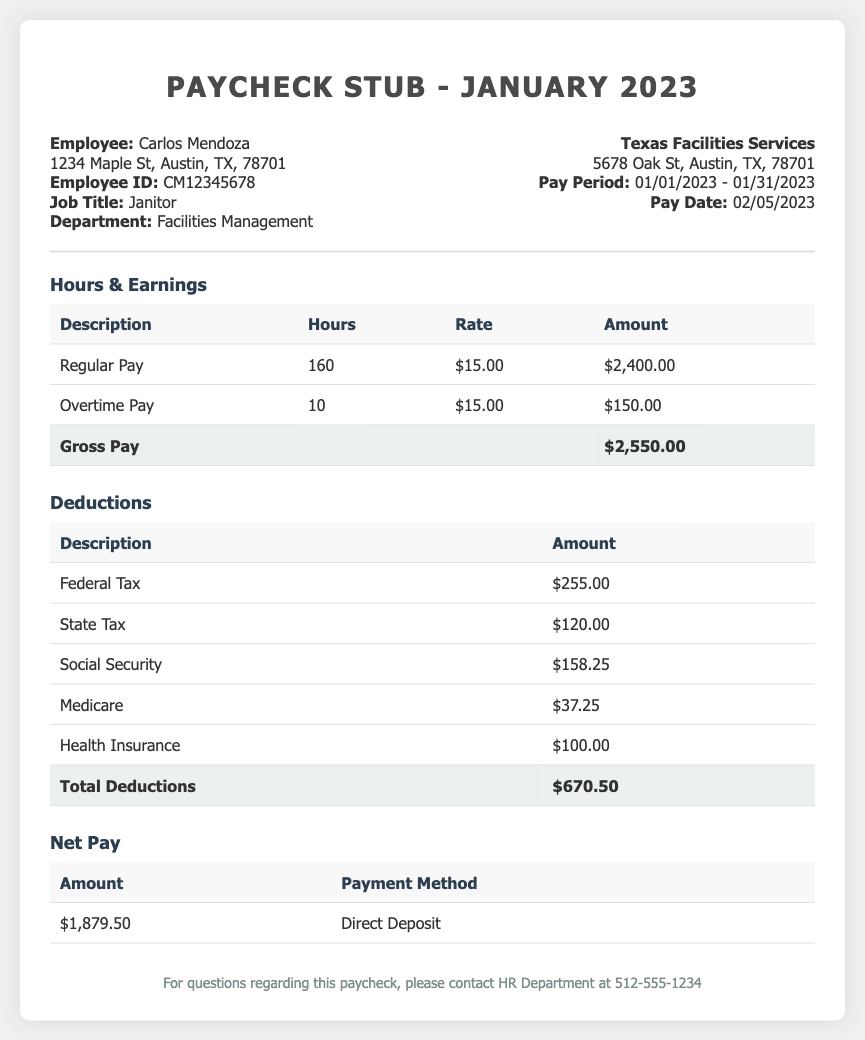What is the employee's name? The employee's name is listed in the document as Carlos Mendoza.
Answer: Carlos Mendoza What is the pay period? The pay period is specified in the document as the time span from January 1, 2023 to January 31, 2023.
Answer: 01/01/2023 - 01/31/2023 How many hours of overtime were worked? The overtime hours are listed in the earnings section of the document as 10 hours.
Answer: 10 What is the total gross pay? The total gross pay is provided in the earnings section as $2,550.00.
Answer: $2,550.00 What is the amount deducted for federal tax? The deduction for federal tax is specified in the deductions section of the document as $255.00.
Answer: $255.00 What is the net pay amount? The net pay amount is stated in the document as $1,879.50.
Answer: $1,879.50 What payment method was used? The payment method for the net pay is indicated as direct deposit in the document.
Answer: Direct Deposit What is the total amount of deductions? The total deductions are calculated and shown in the document as $670.50.
Answer: $670.50 What is the job title of the employee? The job title of the employee is mentioned in the document as janitor.
Answer: Janitor 